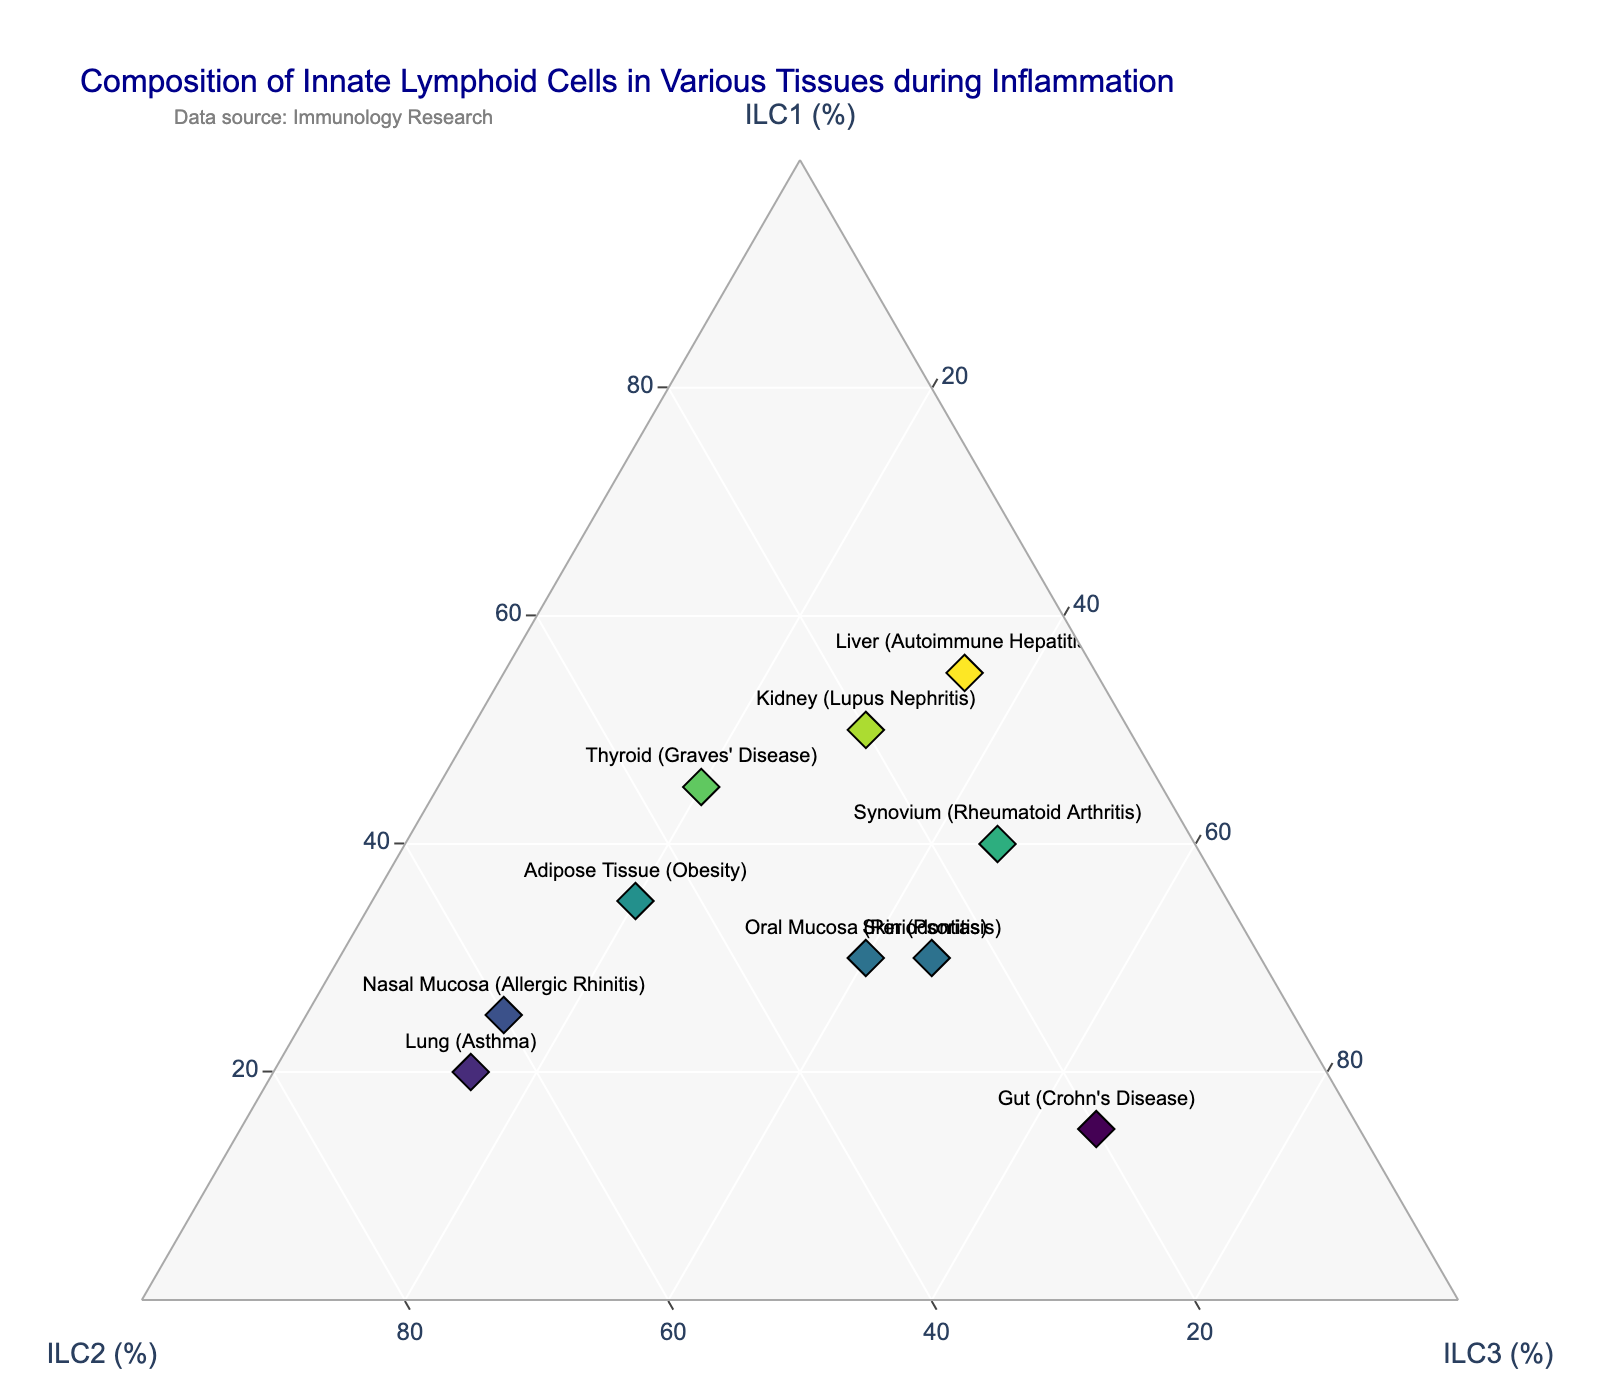What is the title of the figure? The title is usually prominently displayed at the top of the figure. It reads, "Composition of Innate Lymphoid Cells in Various Tissues during Inflammation".
Answer: Composition of Innate Lymphoid Cells in Various Tissues during Inflammation How many tissues are analyzed in this plot? Each point on the ternary plot represents a different tissue sample. By counting the labeled points on the plot, we can determine the number of analyzed tissues.
Answer: 10 Which tissue has the highest percentage of ILC1 cells? The tissue with the highest percentage of ILC1 cells appears as the point closest to the ILC1 axis. In this case, it’s the Liver (Autoimmune Hepatitis) with 55%.
Answer: Liver (Autoimmune Hepatitis) Which tissue has the highest percentage of ILC3 cells? The tissue with the highest percentage of ILC3 cells is the one closest to the ILC3 axis. Here, it’s the Gut (Crohn's Disease) with 65%.
Answer: Gut (Crohn's Disease) What is the difference in ILC2 percentage between Lung (Asthma) and Nasal Mucosa (Allergic Rhinitis)? According to the ternary plot, Lung (Asthma) has 65% ILC2 while Nasal Mucosa (Allergic Rhinitis) has 60% ILC2. The difference is 65% - 60%.
Answer: 5% Among all tissues, which tissue has the most balanced composition of ILC1, ILC2, and ILC3? To identify the tissue with the most balanced composition, look for the point closest to the center of the ternary plot. Oral Mucosa (Periodontitis) has the most balanced composition with 30% ILC1, 30% ILC2, and 40% ILC3.
Answer: Oral Mucosa (Periodontitis) Which tissue has a higher percentage of ILC2 cells: Adipose Tissue (Obesity) or Thyroid (Graves’ Disease)? By examining the ternary plot, Adipose Tissue has 45% ILC2 and Thyroid has 35% ILC2. So, Adipose Tissue has a higher percentage.
Answer: Adipose Tissue (Obesity) What is the composition of ILC cells in the Synovium (Rheumatoid Arthritis)? The composition is shown visually in the ternary plot. For Synovium (Rheumatoid Arthritis), it is 40% ILC1, 15% ILC2, and 45% ILC3.
Answer: 40% ILC1, 15% ILC2, 45% ILC3 Which tissue has an equal percentage of ILC2 and ILC3 cells? By observing the ternary plot, the Skin (Psoriasis) shows equal percentages of ILC2 and ILC3 at 25% each.
Answer: Skin (Psoriasis) 